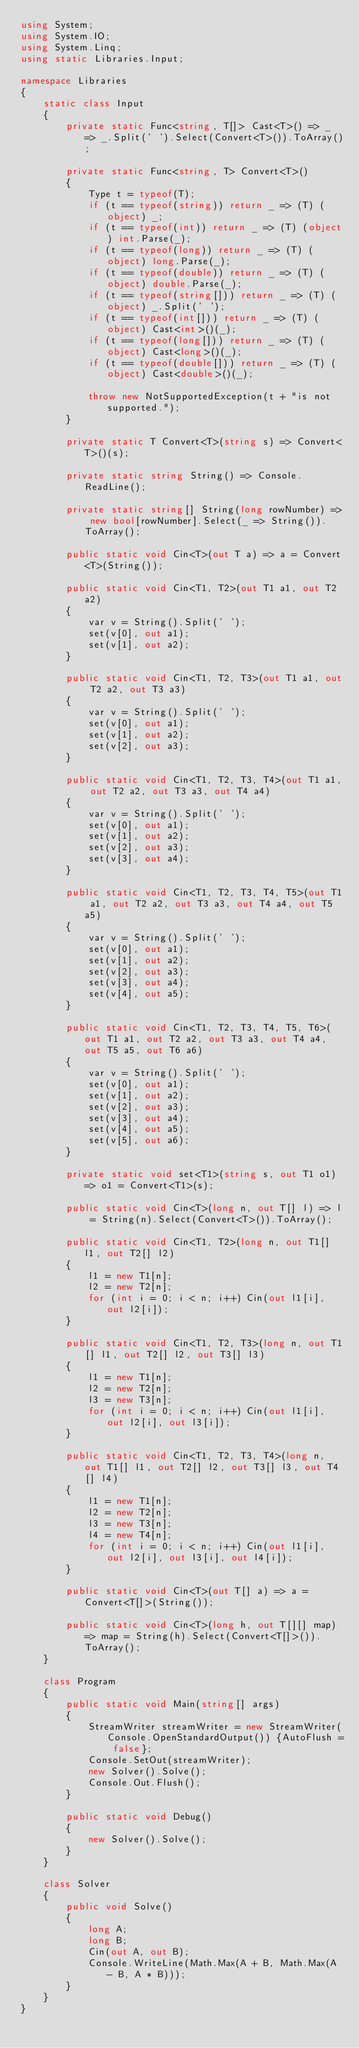<code> <loc_0><loc_0><loc_500><loc_500><_C#_>using System;
using System.IO;
using System.Linq;
using static Libraries.Input;

namespace Libraries
{
    static class Input
    {
        private static Func<string, T[]> Cast<T>() => _ => _.Split(' ').Select(Convert<T>()).ToArray();

        private static Func<string, T> Convert<T>()
        {
            Type t = typeof(T);
            if (t == typeof(string)) return _ => (T) (object) _;
            if (t == typeof(int)) return _ => (T) (object) int.Parse(_);
            if (t == typeof(long)) return _ => (T) (object) long.Parse(_);
            if (t == typeof(double)) return _ => (T) (object) double.Parse(_);
            if (t == typeof(string[])) return _ => (T) (object) _.Split(' ');
            if (t == typeof(int[])) return _ => (T) (object) Cast<int>()(_);
            if (t == typeof(long[])) return _ => (T) (object) Cast<long>()(_);
            if (t == typeof(double[])) return _ => (T) (object) Cast<double>()(_);

            throw new NotSupportedException(t + "is not supported.");
        }

        private static T Convert<T>(string s) => Convert<T>()(s);

        private static string String() => Console.ReadLine();

        private static string[] String(long rowNumber) => new bool[rowNumber].Select(_ => String()).ToArray();

        public static void Cin<T>(out T a) => a = Convert<T>(String());

        public static void Cin<T1, T2>(out T1 a1, out T2 a2)
        {
            var v = String().Split(' ');
            set(v[0], out a1);
            set(v[1], out a2);
        }

        public static void Cin<T1, T2, T3>(out T1 a1, out T2 a2, out T3 a3)
        {
            var v = String().Split(' ');
            set(v[0], out a1);
            set(v[1], out a2);
            set(v[2], out a3);
        }

        public static void Cin<T1, T2, T3, T4>(out T1 a1, out T2 a2, out T3 a3, out T4 a4)
        {
            var v = String().Split(' ');
            set(v[0], out a1);
            set(v[1], out a2);
            set(v[2], out a3);
            set(v[3], out a4);
        }

        public static void Cin<T1, T2, T3, T4, T5>(out T1 a1, out T2 a2, out T3 a3, out T4 a4, out T5 a5)
        {
            var v = String().Split(' ');
            set(v[0], out a1);
            set(v[1], out a2);
            set(v[2], out a3);
            set(v[3], out a4);
            set(v[4], out a5);
        }

        public static void Cin<T1, T2, T3, T4, T5, T6>(out T1 a1, out T2 a2, out T3 a3, out T4 a4, out T5 a5, out T6 a6)
        {
            var v = String().Split(' ');
            set(v[0], out a1);
            set(v[1], out a2);
            set(v[2], out a3);
            set(v[3], out a4);
            set(v[4], out a5);
            set(v[5], out a6);
        }

        private static void set<T1>(string s, out T1 o1) => o1 = Convert<T1>(s);

        public static void Cin<T>(long n, out T[] l) => l = String(n).Select(Convert<T>()).ToArray();

        public static void Cin<T1, T2>(long n, out T1[] l1, out T2[] l2)
        {
            l1 = new T1[n];
            l2 = new T2[n];
            for (int i = 0; i < n; i++) Cin(out l1[i], out l2[i]);
        }

        public static void Cin<T1, T2, T3>(long n, out T1[] l1, out T2[] l2, out T3[] l3)
        {
            l1 = new T1[n];
            l2 = new T2[n];
            l3 = new T3[n];
            for (int i = 0; i < n; i++) Cin(out l1[i], out l2[i], out l3[i]);
        }

        public static void Cin<T1, T2, T3, T4>(long n, out T1[] l1, out T2[] l2, out T3[] l3, out T4[] l4)
        {
            l1 = new T1[n];
            l2 = new T2[n];
            l3 = new T3[n];
            l4 = new T4[n];
            for (int i = 0; i < n; i++) Cin(out l1[i], out l2[i], out l3[i], out l4[i]);
        }

        public static void Cin<T>(out T[] a) => a = Convert<T[]>(String());

        public static void Cin<T>(long h, out T[][] map) => map = String(h).Select(Convert<T[]>()).ToArray();
    }

    class Program
    {
        public static void Main(string[] args)
        {
            StreamWriter streamWriter = new StreamWriter(Console.OpenStandardOutput()) {AutoFlush = false};
            Console.SetOut(streamWriter);
            new Solver().Solve();
            Console.Out.Flush();
        }

        public static void Debug()
        {
            new Solver().Solve();
        }
    }

    class Solver
    {
        public void Solve()
        {
            long A;
            long B;
            Cin(out A, out B);
            Console.WriteLine(Math.Max(A + B, Math.Max(A - B, A * B)));
        }
    }
}</code> 